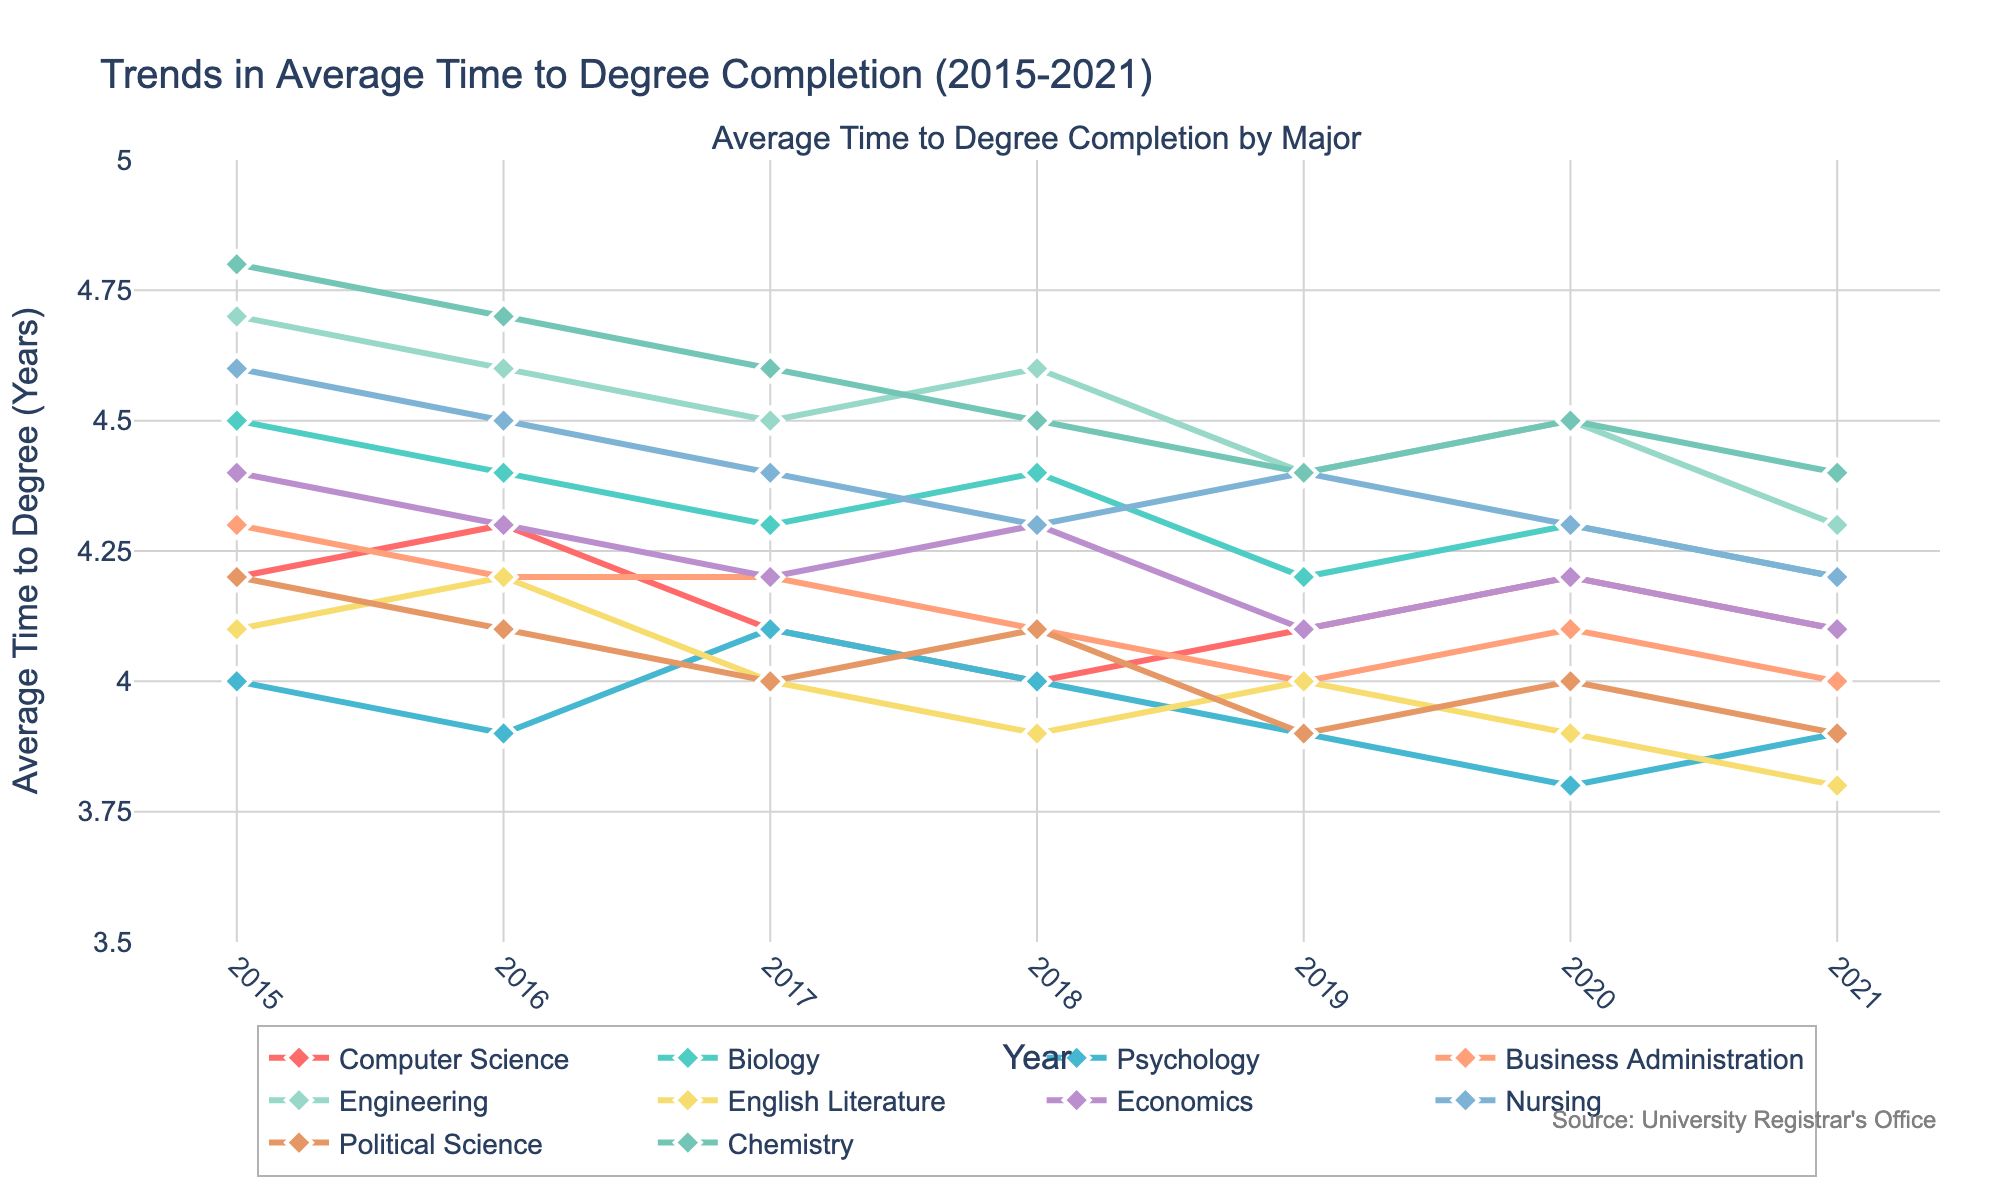What major had the shortest average time to degree completion in 2021? Refer to the end of each line to compare the 2021 values. Psychology has the shortest time (3.9 years).
Answer: Psychology How did the average time to degree completion for Engineering change from 2015 to 2021? Look at the Engineering line from 2015 (4.7 years) to 2021 (4.3 years). The difference is 4.7 - 4.3 = 0.4 years shorter.
Answer: Decreased by 0.4 years Which two majors had almost identical average times to degree completion in 2018? Compare the 2018 values on the chart for all majors. Business Administration and Political Science both had a time of 4.1 years.
Answer: Business Administration and Political Science Which major saw the most significant decrease in average time to degree completion from 2015 to 2021? Calculate the difference for each major between 2015 and 2021, looking for the largest decrease. Chemistry decreased from 4.8 to 4.4 years, by 0.4 years.
Answer: Chemistry What is the overall trend for the average time to degree completion for Nursing from 2015 to 2021? Observe the Nursing line from 2015 (4.6 years) to 2021 (4.2 years). The trend is consistently decreasing.
Answer: Decreasing Among Computer Science, Biology, and Economics, which major had the lowest average time to degree completion in 2017? Compare the 2017 values for these majors. Computer Science had the smallest time (4.1 years).
Answer: Computer Science What was the average time to degree completion across all majors in 2020? Sum the 2020 values and divide by the number of majors (10). The sum is 4.2+4.3+3.8+4.1+4.5+3.9+4.2+4.3+4.0+4.5 = 41.8; 41.8 / 10 = 4.18 years.
Answer: 4.18 years Which major had the least variation in average time to degree completion from 2015 to 2021? Observe the lines' fluctuations; Business Administration appears stable with only slight changes (4.3 to 4.0 years).
Answer: Business Administration 